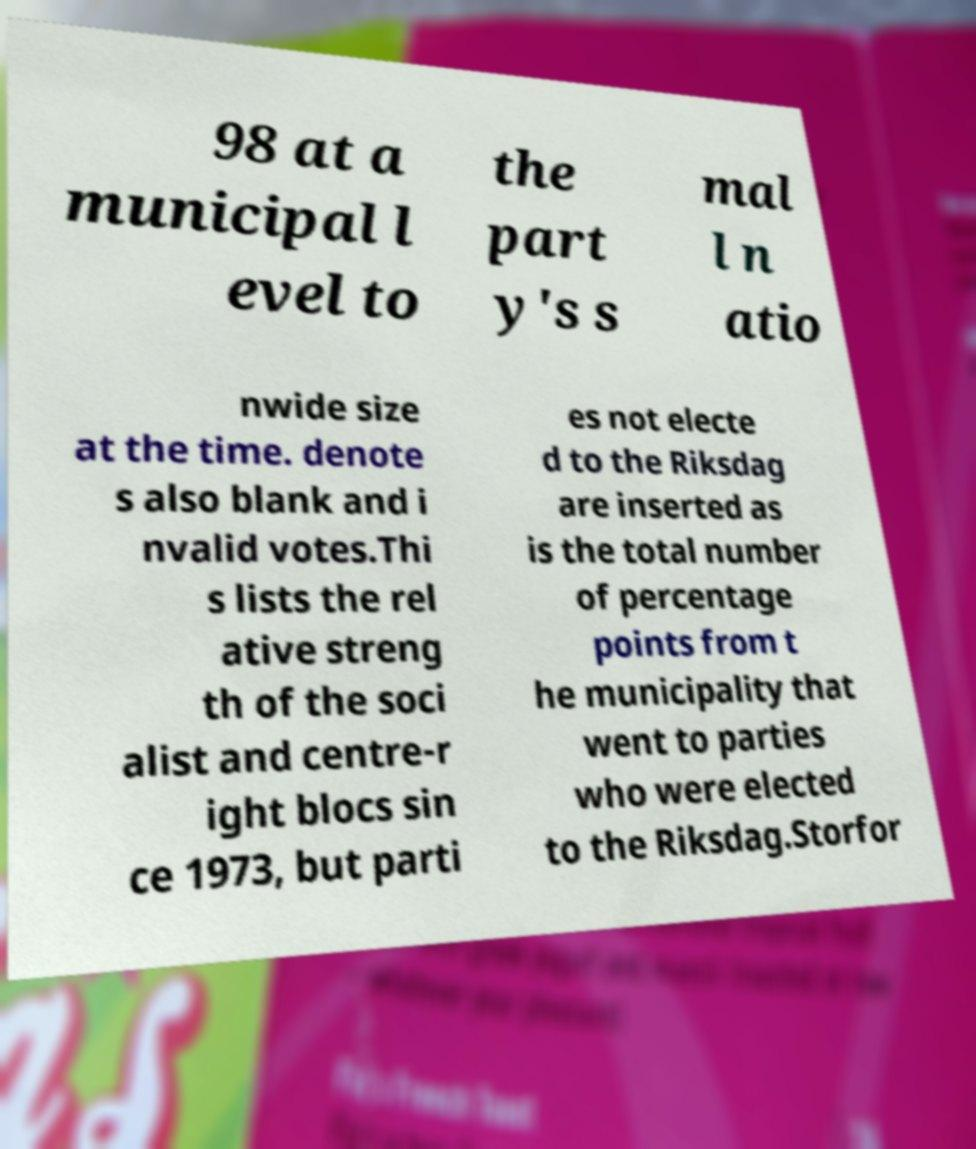I need the written content from this picture converted into text. Can you do that? 98 at a municipal l evel to the part y's s mal l n atio nwide size at the time. denote s also blank and i nvalid votes.Thi s lists the rel ative streng th of the soci alist and centre-r ight blocs sin ce 1973, but parti es not electe d to the Riksdag are inserted as is the total number of percentage points from t he municipality that went to parties who were elected to the Riksdag.Storfor 